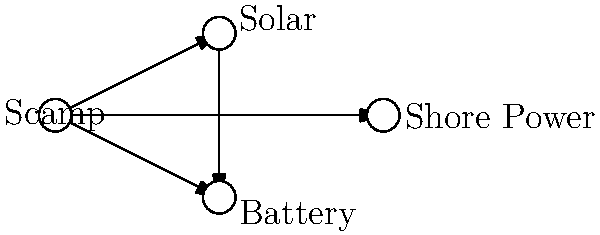In the network diagram of a Scamp trailer's power connectivity options, how many direct connections does the Scamp have to different power sources, and what is the total number of connections in the entire network? To answer this question, we need to analyze the network diagram step-by-step:

1. Identify the Scamp node:
   The Scamp is represented by the leftmost node in the diagram.

2. Count direct connections from the Scamp:
   a) Scamp to Solar
   b) Scamp to Battery
   c) Scamp to Shore Power
   The Scamp has 3 direct connections to different power sources.

3. Count all connections in the network:
   a) Scamp to Solar
   b) Scamp to Battery
   c) Scamp to Shore Power
   d) Solar to Battery
   The total number of connections in the entire network is 4.

Therefore, the Scamp has 3 direct connections to different power sources, and there are 4 total connections in the entire network.
Answer: 3 direct connections, 4 total connections 